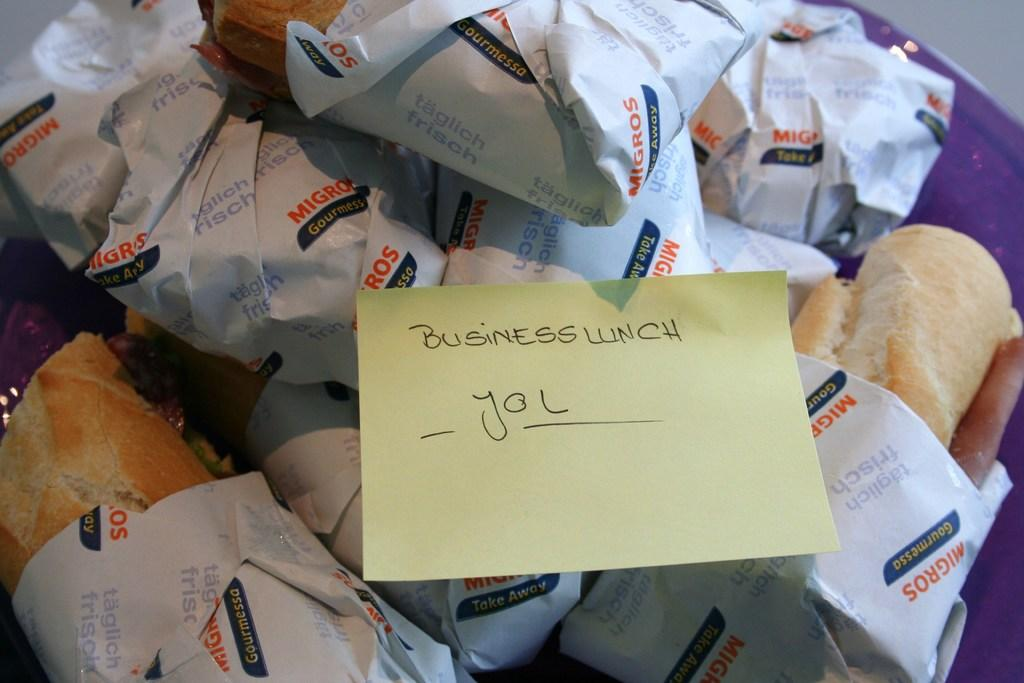What can be seen in the image related to food? There are multiple packed food items in the image. Is there any additional information provided with the food items? Yes, there is a small piece of paper with writing on it in the image. What type of error can be seen on the notebook in the image? There is no notebook present in the image, so it is not possible to determine if there is any error on it. 